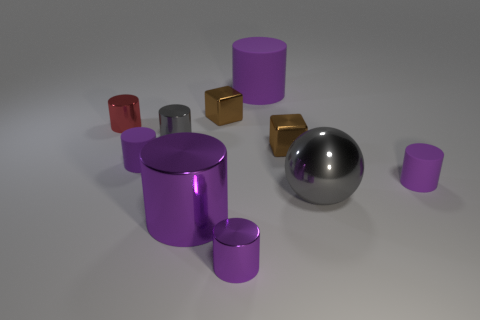Subtract all red metallic cylinders. How many cylinders are left? 6 Subtract all cubes. How many objects are left? 8 Subtract 1 cubes. How many cubes are left? 1 Subtract all cyan cubes. How many purple cylinders are left? 5 Subtract all tiny brown metallic cubes. Subtract all small metallic blocks. How many objects are left? 6 Add 3 brown shiny things. How many brown shiny things are left? 5 Add 3 small shiny objects. How many small shiny objects exist? 8 Subtract all purple cylinders. How many cylinders are left? 2 Subtract 0 cyan cylinders. How many objects are left? 10 Subtract all brown cylinders. Subtract all yellow blocks. How many cylinders are left? 7 